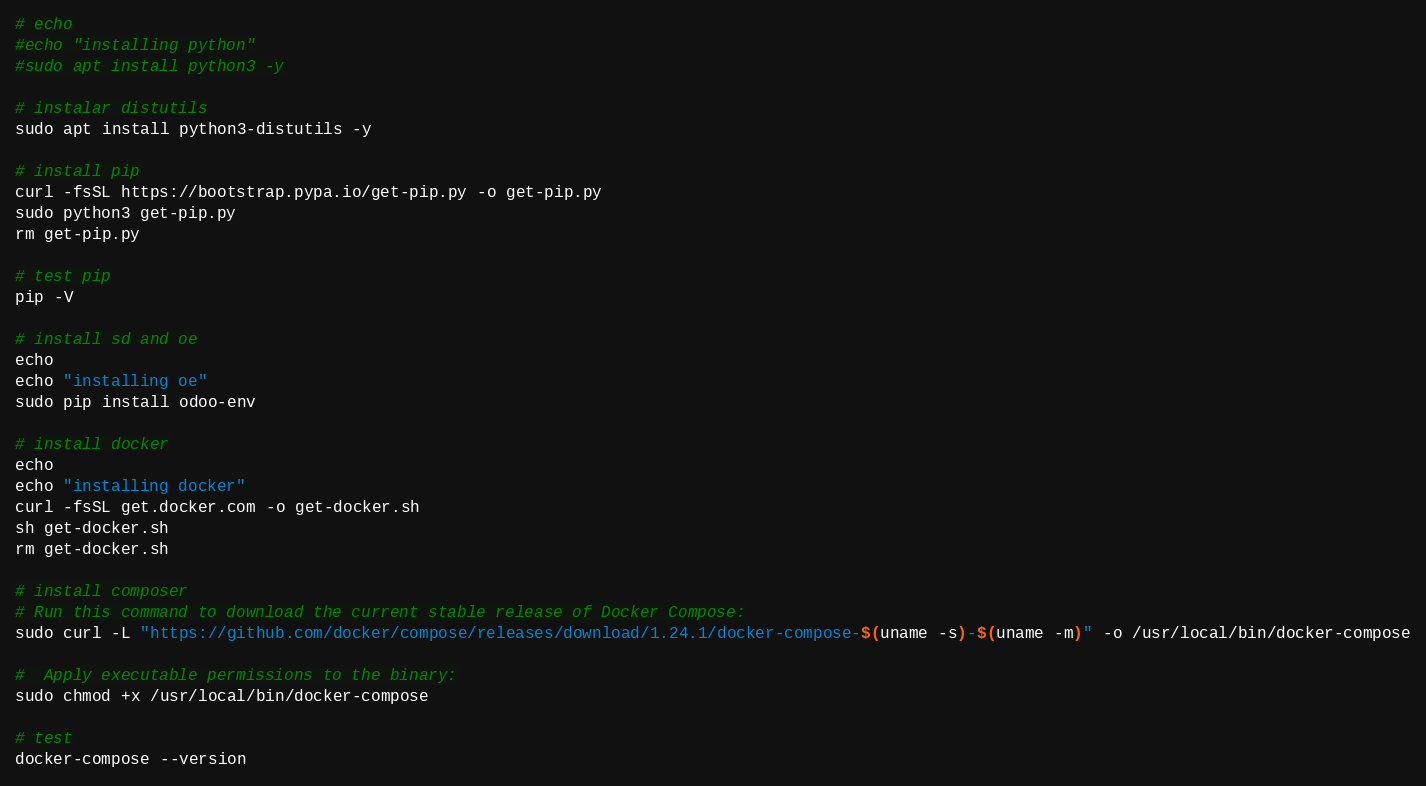<code> <loc_0><loc_0><loc_500><loc_500><_Bash_># echo
#echo "installing python"
#sudo apt install python3 -y

# instalar distutils
sudo apt install python3-distutils -y

# install pip
curl -fsSL https://bootstrap.pypa.io/get-pip.py -o get-pip.py
sudo python3 get-pip.py
rm get-pip.py

# test pip
pip -V

# install sd and oe
echo
echo "installing oe"
sudo pip install odoo-env

# install docker
echo
echo "installing docker"
curl -fsSL get.docker.com -o get-docker.sh
sh get-docker.sh
rm get-docker.sh

# install composer
# Run this command to download the current stable release of Docker Compose:
sudo curl -L "https://github.com/docker/compose/releases/download/1.24.1/docker-compose-$(uname -s)-$(uname -m)" -o /usr/local/bin/docker-compose

#  Apply executable permissions to the binary:
sudo chmod +x /usr/local/bin/docker-compose

# test
docker-compose --version
</code> 